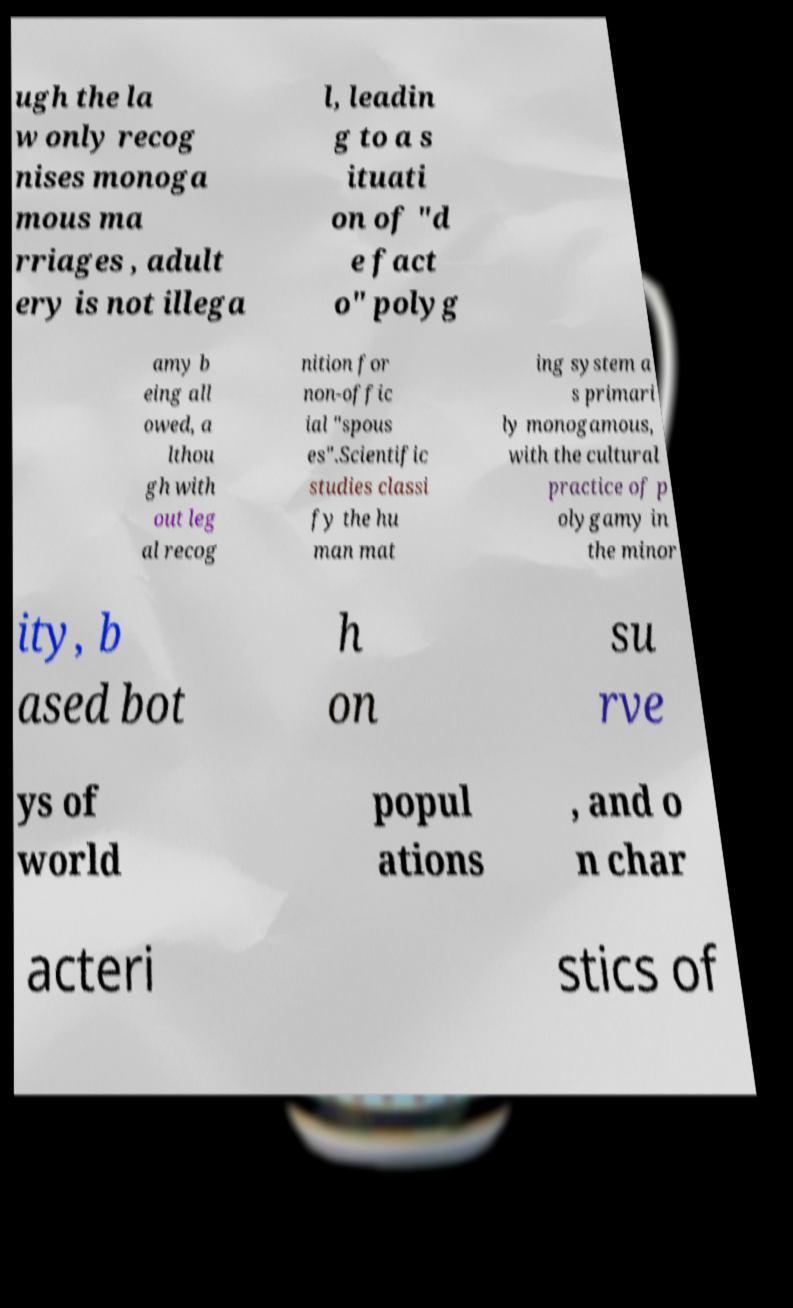Could you assist in decoding the text presented in this image and type it out clearly? ugh the la w only recog nises monoga mous ma rriages , adult ery is not illega l, leadin g to a s ituati on of "d e fact o" polyg amy b eing all owed, a lthou gh with out leg al recog nition for non-offic ial "spous es".Scientific studies classi fy the hu man mat ing system a s primari ly monogamous, with the cultural practice of p olygamy in the minor ity, b ased bot h on su rve ys of world popul ations , and o n char acteri stics of 